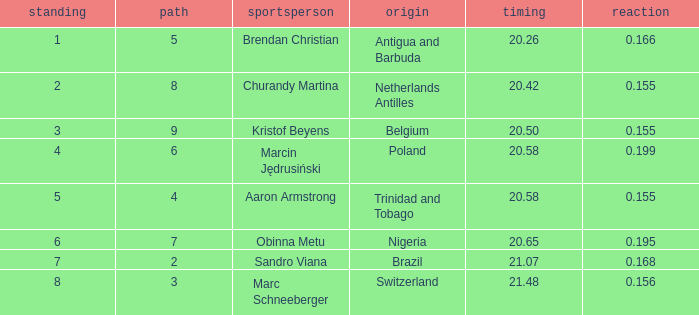How much Time has a Reaction of 0.155, and an Athlete of kristof beyens, and a Rank smaller than 3? 0.0. 